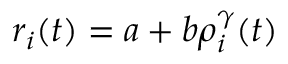Convert formula to latex. <formula><loc_0><loc_0><loc_500><loc_500>\begin{array} { r } { r _ { i } ( t ) = a + b \rho _ { i } ^ { \gamma } ( t ) } \end{array}</formula> 